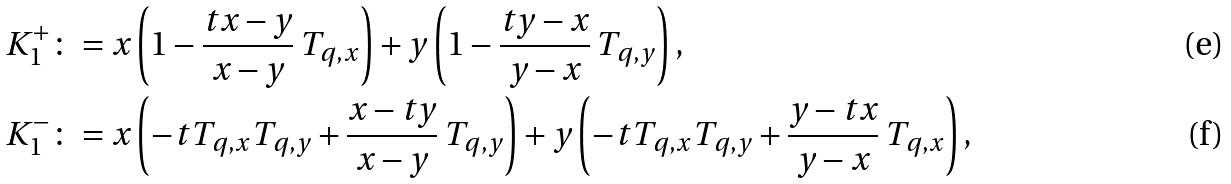<formula> <loc_0><loc_0><loc_500><loc_500>K _ { 1 } ^ { + } & \colon = x \left ( 1 - \frac { t x - y } { x - y } \, T _ { q , x } \right ) + y \left ( 1 - \frac { t y - x } { y - x } \, T _ { q , y } \right ) , \\ K _ { 1 } ^ { - } & \colon = x \left ( - t T _ { q , x } T _ { q , y } + \frac { x - t y } { x - y } \, T _ { q , y } \right ) + y \left ( - t T _ { q , x } T _ { q , y } + \frac { y - t x } { y - x } \, T _ { q , x } \right ) ,</formula> 